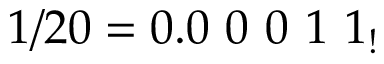<formula> <loc_0><loc_0><loc_500><loc_500>1 / 2 0 = 0 . 0 \ 0 \ 0 \ 1 \ 1 _ { ! }</formula> 